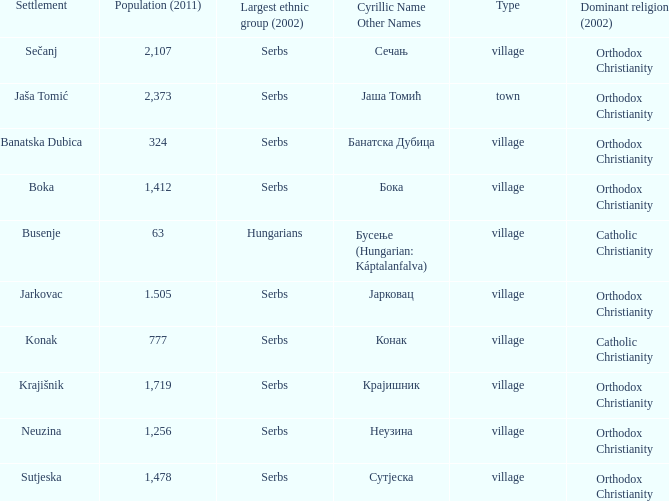What kind of type is  бока? Village. 